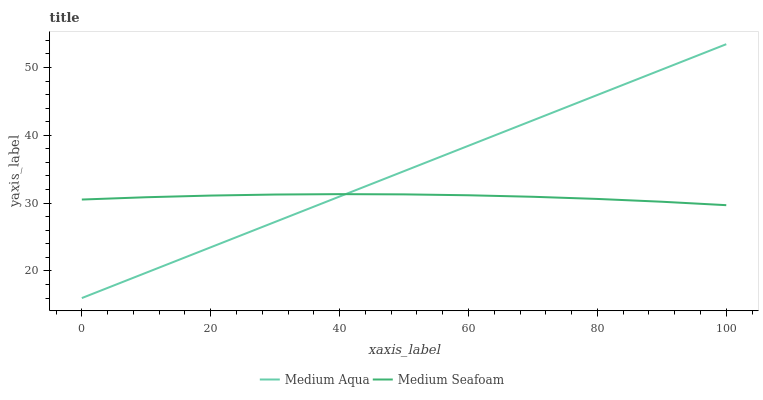Does Medium Seafoam have the minimum area under the curve?
Answer yes or no. Yes. Does Medium Aqua have the maximum area under the curve?
Answer yes or no. Yes. Does Medium Seafoam have the maximum area under the curve?
Answer yes or no. No. Is Medium Aqua the smoothest?
Answer yes or no. Yes. Is Medium Seafoam the roughest?
Answer yes or no. Yes. Is Medium Seafoam the smoothest?
Answer yes or no. No. Does Medium Aqua have the lowest value?
Answer yes or no. Yes. Does Medium Seafoam have the lowest value?
Answer yes or no. No. Does Medium Aqua have the highest value?
Answer yes or no. Yes. Does Medium Seafoam have the highest value?
Answer yes or no. No. Does Medium Aqua intersect Medium Seafoam?
Answer yes or no. Yes. Is Medium Aqua less than Medium Seafoam?
Answer yes or no. No. Is Medium Aqua greater than Medium Seafoam?
Answer yes or no. No. 